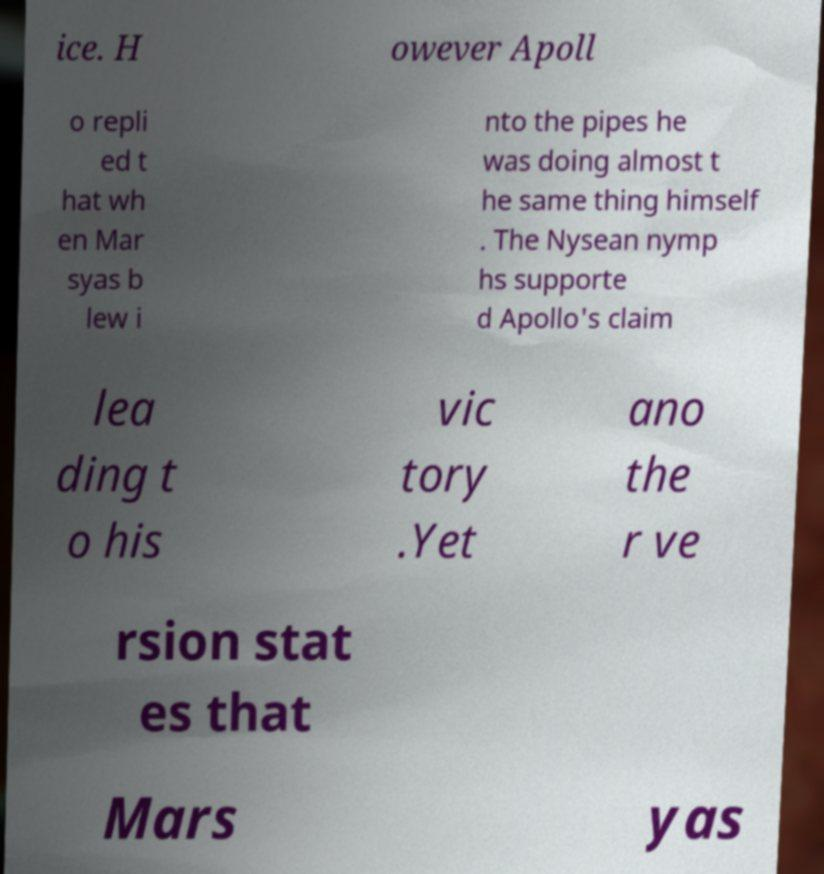For documentation purposes, I need the text within this image transcribed. Could you provide that? ice. H owever Apoll o repli ed t hat wh en Mar syas b lew i nto the pipes he was doing almost t he same thing himself . The Nysean nymp hs supporte d Apollo's claim lea ding t o his vic tory .Yet ano the r ve rsion stat es that Mars yas 